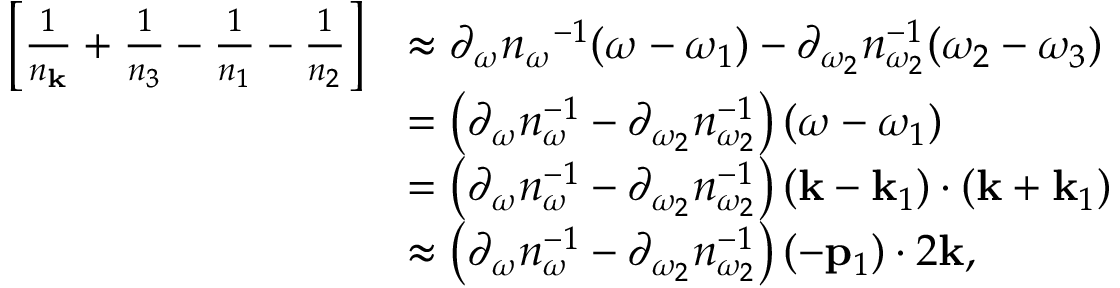<formula> <loc_0><loc_0><loc_500><loc_500>\begin{array} { r l } { \left [ \frac { 1 } { n _ { k } } + \frac { 1 } { n _ { 3 } } - \frac { 1 } { n _ { 1 } } - \frac { 1 } { n _ { 2 } } \right ] } & { \approx \partial _ { \omega } { n _ { \omega } } ^ { - 1 } ( \omega - \omega _ { 1 } ) - \partial _ { \omega _ { 2 } } n _ { \omega _ { 2 } } ^ { - 1 } ( \omega _ { 2 } - \omega _ { 3 } ) } \\ & { = \left ( \partial _ { \omega } n _ { \omega } ^ { - 1 } - \partial _ { \omega _ { 2 } } n _ { \omega _ { 2 } } ^ { - 1 } \right ) ( \omega - \omega _ { 1 } ) } \\ & { = \left ( \partial _ { \omega } n _ { \omega } ^ { - 1 } - \partial _ { \omega _ { 2 } } n _ { \omega _ { 2 } } ^ { - 1 } \right ) ( { k } - { k } _ { 1 } ) \cdot ( { k } + { k } _ { 1 } ) } \\ & { \approx \left ( \partial _ { \omega } n _ { \omega } ^ { - 1 } - \partial _ { \omega _ { 2 } } n _ { \omega _ { 2 } } ^ { - 1 } \right ) ( - { p } _ { 1 } ) \cdot 2 { k } , } \end{array}</formula> 